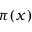Convert formula to latex. <formula><loc_0><loc_0><loc_500><loc_500>\pi ( x )</formula> 